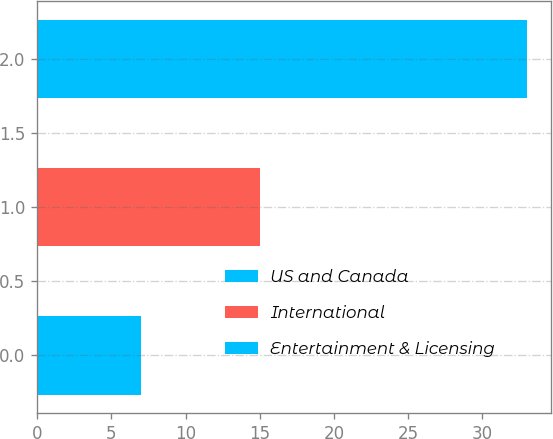<chart> <loc_0><loc_0><loc_500><loc_500><bar_chart><fcel>US and Canada<fcel>International<fcel>Entertainment & Licensing<nl><fcel>7<fcel>15<fcel>33<nl></chart> 